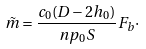<formula> <loc_0><loc_0><loc_500><loc_500>\tilde { m } = \frac { c _ { 0 } ( D - 2 h _ { 0 } ) } { n p _ { 0 } S } F _ { b } \cdot</formula> 